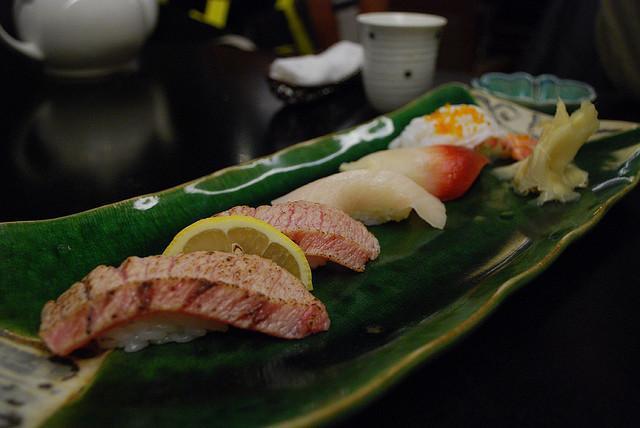How many bowls are in the picture?
Give a very brief answer. 1. How many motorcycles have an american flag on them?
Give a very brief answer. 0. 